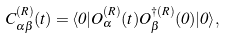Convert formula to latex. <formula><loc_0><loc_0><loc_500><loc_500>C ^ { ( R ) } _ { \alpha \beta } ( t ) = \langle 0 | O ^ { ( R ) } _ { \alpha } ( t ) O ^ { \dagger ( R ) } _ { \beta } ( 0 ) | 0 \rangle ,</formula> 